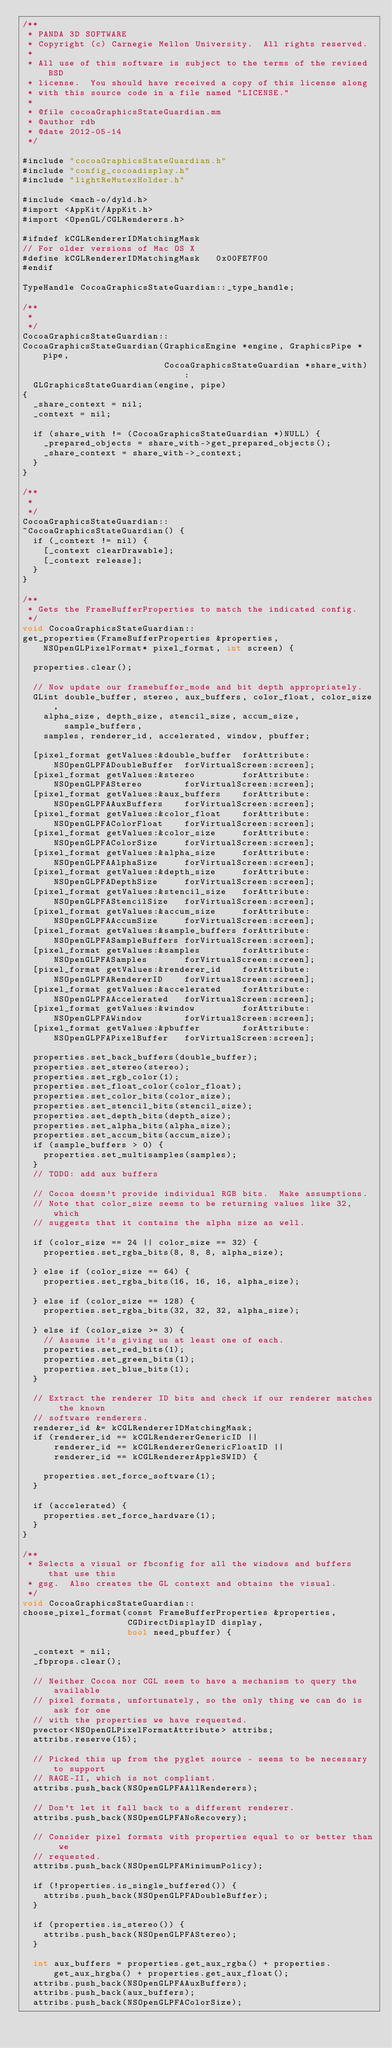<code> <loc_0><loc_0><loc_500><loc_500><_ObjectiveC_>/**
 * PANDA 3D SOFTWARE
 * Copyright (c) Carnegie Mellon University.  All rights reserved.
 *
 * All use of this software is subject to the terms of the revised BSD
 * license.  You should have received a copy of this license along
 * with this source code in a file named "LICENSE."
 *
 * @file cocoaGraphicsStateGuardian.mm
 * @author rdb
 * @date 2012-05-14
 */

#include "cocoaGraphicsStateGuardian.h"
#include "config_cocoadisplay.h"
#include "lightReMutexHolder.h"

#include <mach-o/dyld.h>
#import <AppKit/AppKit.h>
#import <OpenGL/CGLRenderers.h>

#ifndef kCGLRendererIDMatchingMask
// For older versions of Mac OS X
#define kCGLRendererIDMatchingMask   0x00FE7F00
#endif

TypeHandle CocoaGraphicsStateGuardian::_type_handle;

/**
 *
 */
CocoaGraphicsStateGuardian::
CocoaGraphicsStateGuardian(GraphicsEngine *engine, GraphicsPipe *pipe,
                           CocoaGraphicsStateGuardian *share_with) :
  GLGraphicsStateGuardian(engine, pipe)
{
  _share_context = nil;
  _context = nil;

  if (share_with != (CocoaGraphicsStateGuardian *)NULL) {
    _prepared_objects = share_with->get_prepared_objects();
    _share_context = share_with->_context;
  }
}

/**
 *
 */
CocoaGraphicsStateGuardian::
~CocoaGraphicsStateGuardian() {
  if (_context != nil) {
    [_context clearDrawable];
    [_context release];
  }
}

/**
 * Gets the FrameBufferProperties to match the indicated config.
 */
void CocoaGraphicsStateGuardian::
get_properties(FrameBufferProperties &properties, NSOpenGLPixelFormat* pixel_format, int screen) {

  properties.clear();

  // Now update our framebuffer_mode and bit depth appropriately.
  GLint double_buffer, stereo, aux_buffers, color_float, color_size,
    alpha_size, depth_size, stencil_size, accum_size, sample_buffers,
    samples, renderer_id, accelerated, window, pbuffer;

  [pixel_format getValues:&double_buffer  forAttribute:NSOpenGLPFADoubleBuffer  forVirtualScreen:screen];
  [pixel_format getValues:&stereo         forAttribute:NSOpenGLPFAStereo        forVirtualScreen:screen];
  [pixel_format getValues:&aux_buffers    forAttribute:NSOpenGLPFAAuxBuffers    forVirtualScreen:screen];
  [pixel_format getValues:&color_float    forAttribute:NSOpenGLPFAColorFloat    forVirtualScreen:screen];
  [pixel_format getValues:&color_size     forAttribute:NSOpenGLPFAColorSize     forVirtualScreen:screen];
  [pixel_format getValues:&alpha_size     forAttribute:NSOpenGLPFAAlphaSize     forVirtualScreen:screen];
  [pixel_format getValues:&depth_size     forAttribute:NSOpenGLPFADepthSize     forVirtualScreen:screen];
  [pixel_format getValues:&stencil_size   forAttribute:NSOpenGLPFAStencilSize   forVirtualScreen:screen];
  [pixel_format getValues:&accum_size     forAttribute:NSOpenGLPFAAccumSize     forVirtualScreen:screen];
  [pixel_format getValues:&sample_buffers forAttribute:NSOpenGLPFASampleBuffers forVirtualScreen:screen];
  [pixel_format getValues:&samples        forAttribute:NSOpenGLPFASamples       forVirtualScreen:screen];
  [pixel_format getValues:&renderer_id    forAttribute:NSOpenGLPFARendererID    forVirtualScreen:screen];
  [pixel_format getValues:&accelerated    forAttribute:NSOpenGLPFAAccelerated   forVirtualScreen:screen];
  [pixel_format getValues:&window         forAttribute:NSOpenGLPFAWindow        forVirtualScreen:screen];
  [pixel_format getValues:&pbuffer        forAttribute:NSOpenGLPFAPixelBuffer   forVirtualScreen:screen];

  properties.set_back_buffers(double_buffer);
  properties.set_stereo(stereo);
  properties.set_rgb_color(1);
  properties.set_float_color(color_float);
  properties.set_color_bits(color_size);
  properties.set_stencil_bits(stencil_size);
  properties.set_depth_bits(depth_size);
  properties.set_alpha_bits(alpha_size);
  properties.set_accum_bits(accum_size);
  if (sample_buffers > 0) {
    properties.set_multisamples(samples);
  }
  // TODO: add aux buffers

  // Cocoa doesn't provide individual RGB bits.  Make assumptions.
  // Note that color_size seems to be returning values like 32, which
  // suggests that it contains the alpha size as well.

  if (color_size == 24 || color_size == 32) {
    properties.set_rgba_bits(8, 8, 8, alpha_size);

  } else if (color_size == 64) {
    properties.set_rgba_bits(16, 16, 16, alpha_size);

  } else if (color_size == 128) {
    properties.set_rgba_bits(32, 32, 32, alpha_size);

  } else if (color_size >= 3) {
    // Assume it's giving us at least one of each.
    properties.set_red_bits(1);
    properties.set_green_bits(1);
    properties.set_blue_bits(1);
  }

  // Extract the renderer ID bits and check if our renderer matches the known
  // software renderers.
  renderer_id &= kCGLRendererIDMatchingMask;
  if (renderer_id == kCGLRendererGenericID ||
      renderer_id == kCGLRendererGenericFloatID ||
      renderer_id == kCGLRendererAppleSWID) {

    properties.set_force_software(1);
  }

  if (accelerated) {
    properties.set_force_hardware(1);
  }
}

/**
 * Selects a visual or fbconfig for all the windows and buffers that use this
 * gsg.  Also creates the GL context and obtains the visual.
 */
void CocoaGraphicsStateGuardian::
choose_pixel_format(const FrameBufferProperties &properties,
                    CGDirectDisplayID display,
                    bool need_pbuffer) {

  _context = nil;
  _fbprops.clear();

  // Neither Cocoa nor CGL seem to have a mechanism to query the available
  // pixel formats, unfortunately, so the only thing we can do is ask for one
  // with the properties we have requested.
  pvector<NSOpenGLPixelFormatAttribute> attribs;
  attribs.reserve(15);

  // Picked this up from the pyglet source - seems to be necessary to support
  // RAGE-II, which is not compliant.
  attribs.push_back(NSOpenGLPFAAllRenderers);

  // Don't let it fall back to a different renderer.
  attribs.push_back(NSOpenGLPFANoRecovery);

  // Consider pixel formats with properties equal to or better than we
  // requested.
  attribs.push_back(NSOpenGLPFAMinimumPolicy);

  if (!properties.is_single_buffered()) {
    attribs.push_back(NSOpenGLPFADoubleBuffer);
  }

  if (properties.is_stereo()) {
    attribs.push_back(NSOpenGLPFAStereo);
  }

  int aux_buffers = properties.get_aux_rgba() + properties.get_aux_hrgba() + properties.get_aux_float();
  attribs.push_back(NSOpenGLPFAAuxBuffers);
  attribs.push_back(aux_buffers);
  attribs.push_back(NSOpenGLPFAColorSize);</code> 